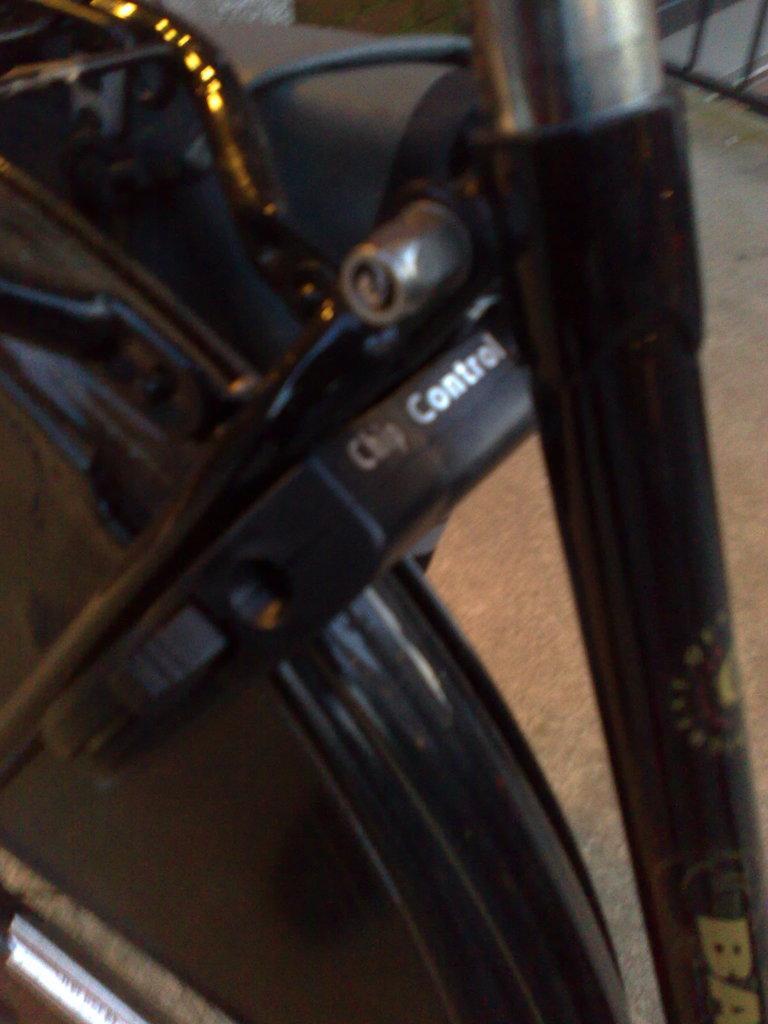Can you describe this image briefly? Here we can see vehicle on the surface. 